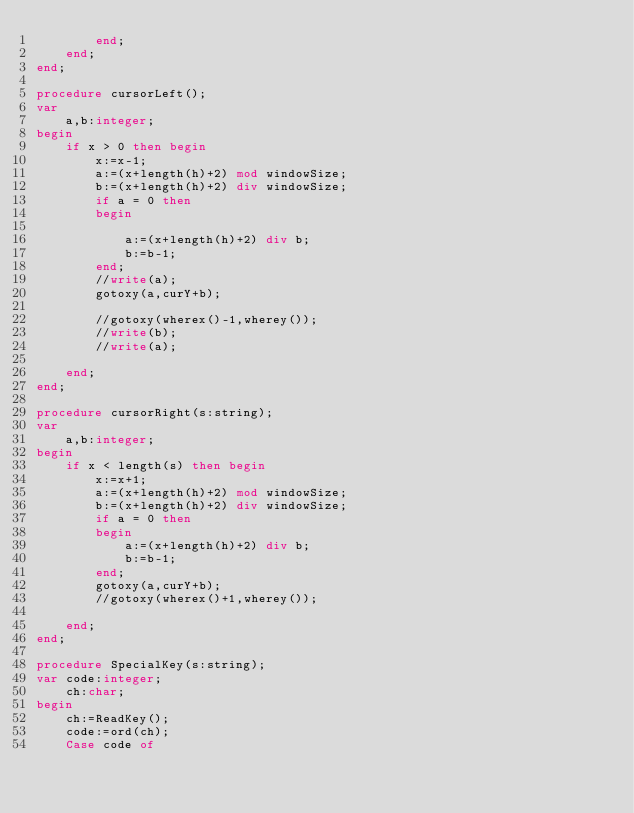<code> <loc_0><loc_0><loc_500><loc_500><_Pascal_>        end;
    end;
end;

procedure cursorLeft();
var
    a,b:integer;
begin
    if x > 0 then begin
        x:=x-1;
        a:=(x+length(h)+2) mod windowSize;
        b:=(x+length(h)+2) div windowSize;
        if a = 0 then 
        begin
            
            a:=(x+length(h)+2) div b;
            b:=b-1;
        end;
        //write(a);
        gotoxy(a,curY+b);
        
        //gotoxy(wherex()-1,wherey());
        //write(b);
        //write(a);
        
    end;
end;

procedure cursorRight(s:string);
var 
    a,b:integer;
begin
    if x < length(s) then begin
        x:=x+1;
        a:=(x+length(h)+2) mod windowSize;
        b:=(x+length(h)+2) div windowSize;
        if a = 0 then 
        begin
            a:=(x+length(h)+2) div b;
            b:=b-1;
        end;
        gotoxy(a,curY+b);
        //gotoxy(wherex()+1,wherey());
        
    end;
end;

procedure SpecialKey(s:string);
var code:integer;
    ch:char;
begin
    ch:=ReadKey();
    code:=ord(ch);
    Case code of </code> 